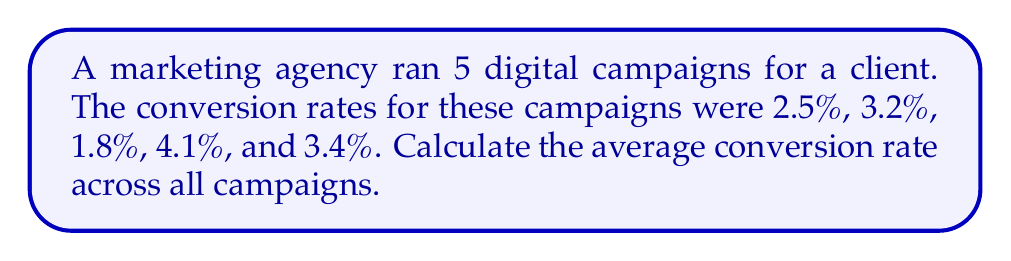Provide a solution to this math problem. To calculate the average conversion rate, we need to follow these steps:

1. Sum up all the conversion rates:
   $$ 2.5\% + 3.2\% + 1.8\% + 4.1\% + 3.4\% $$

2. Convert percentages to decimals:
   $$ 0.025 + 0.032 + 0.018 + 0.041 + 0.034 = 0.15 $$

3. Divide the sum by the number of campaigns (5):
   $$ \frac{0.15}{5} = 0.03 $$

4. Convert the result back to a percentage:
   $$ 0.03 \times 100\% = 3\% $$

Therefore, the average conversion rate across all campaigns is 3%.
Answer: 3% 